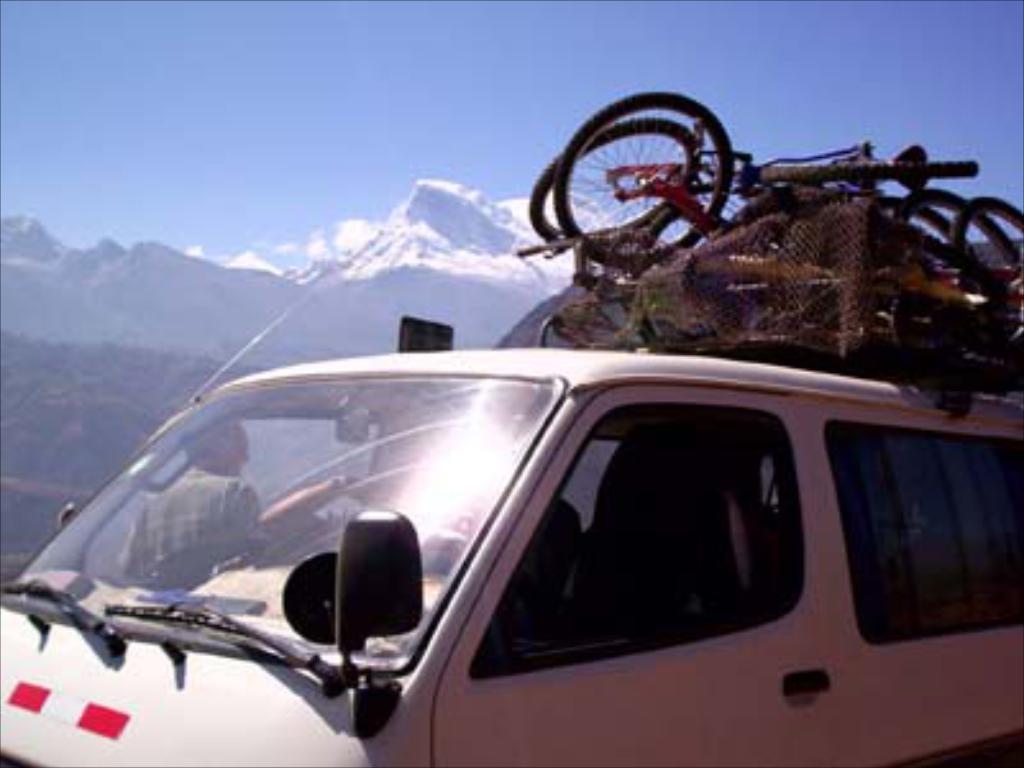Could you give a brief overview of what you see in this image? In this image we can see there is the vehicle. On top of the vehicle we can see the bicycles. And at the back there are mountains and the sky. 